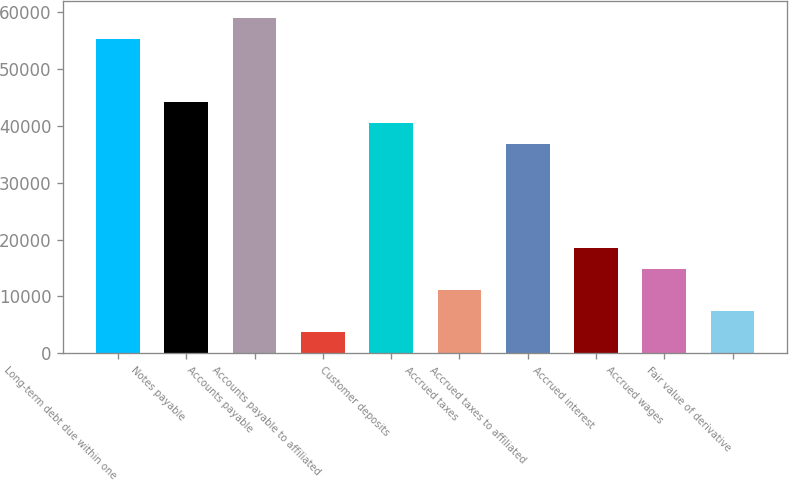<chart> <loc_0><loc_0><loc_500><loc_500><bar_chart><fcel>Long-term debt due within one<fcel>Notes payable<fcel>Accounts payable<fcel>Accounts payable to affiliated<fcel>Customer deposits<fcel>Accrued taxes<fcel>Accrued taxes to affiliated<fcel>Accrued interest<fcel>Accrued wages<fcel>Fair value of derivative<nl><fcel>55326.5<fcel>44261.6<fcel>59014.8<fcel>3690.3<fcel>40573.3<fcel>11066.9<fcel>36885<fcel>18443.5<fcel>14755.2<fcel>7378.6<nl></chart> 